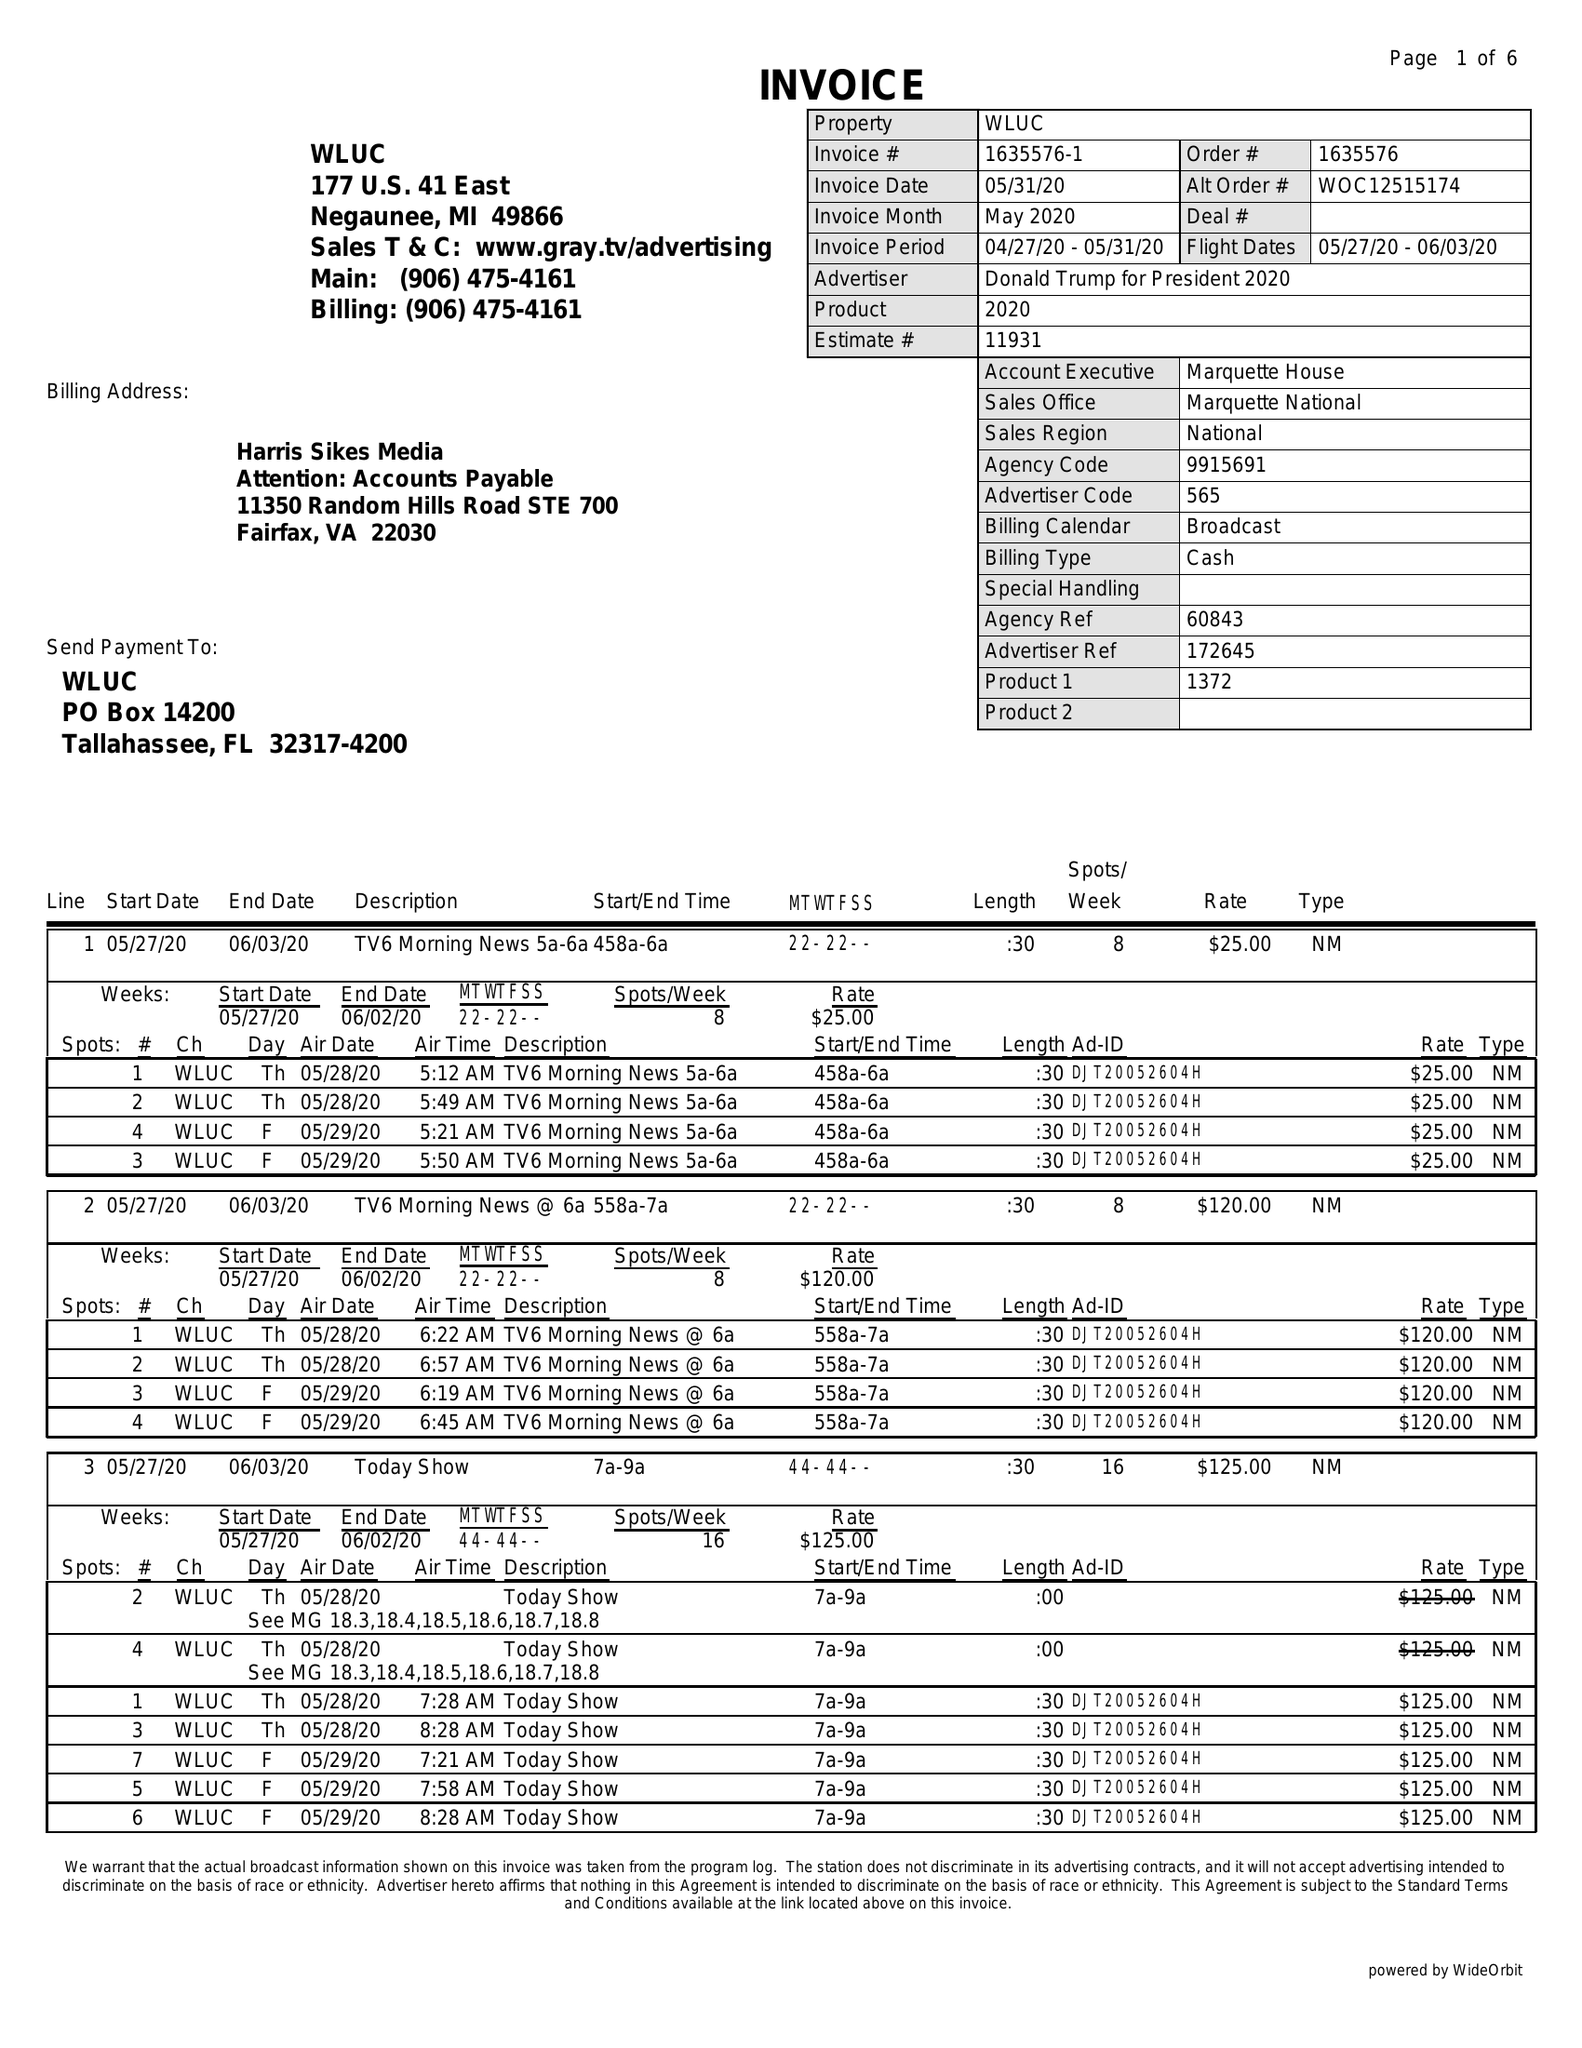What is the value for the contract_num?
Answer the question using a single word or phrase. 1635576 